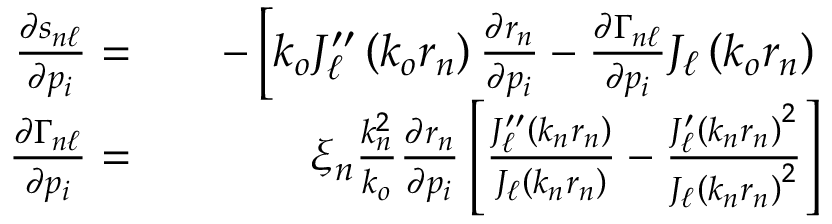<formula> <loc_0><loc_0><loc_500><loc_500>\begin{array} { r l r } { \frac { \partial s _ { n \ell } } { \partial p _ { i } } = } & { - \left [ k _ { o } J _ { \ell } ^ { \prime \prime } \left ( k _ { o } r _ { n } \right ) \frac { \partial r _ { n } } { \partial p _ { i } } - \frac { \partial \Gamma _ { n \ell } } { \partial p _ { i } } J _ { \ell } \left ( k _ { o } r _ { n } \right ) } \\ { \frac { \partial \Gamma _ { n \ell } } { \partial p _ { i } } = } & { \xi _ { n } \frac { k _ { n } ^ { 2 } } { k _ { o } } \frac { \partial r _ { n } } { \partial p _ { i } } \left [ \frac { J _ { \ell } ^ { \prime \prime } \left ( k _ { n } r _ { n } \right ) } { J _ { \ell } \left ( k _ { n } r _ { n } \right ) } - \frac { J _ { \ell } ^ { \prime } \left ( k _ { n } r _ { n } \right ) ^ { 2 } } { J _ { \ell } \left ( k _ { n } r _ { n } \right ) ^ { 2 } } \right ] } \end{array}</formula> 